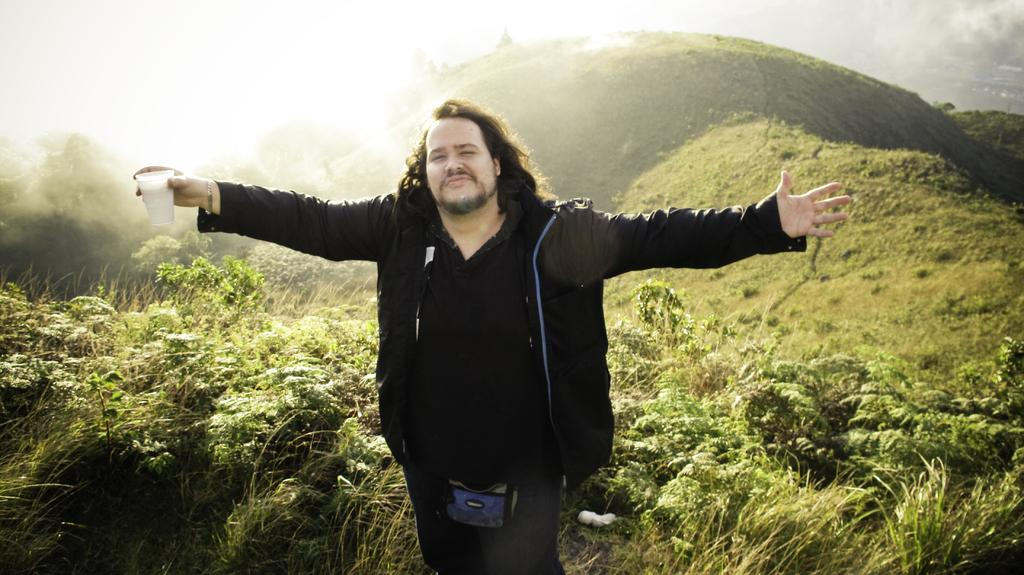What is the main subject of the image? There is a person standing in the image. What can be seen in the background of the image? There are trees behind the person. What type of vegetation is present in the image? There are plants and grass visible in the image. How much salt is visible on the person's hands in the image? There is no salt visible on the person's hands in the image. What type of art can be seen hanging on the trees in the image? There is no art present in the image; it features a person standing in front of trees. 